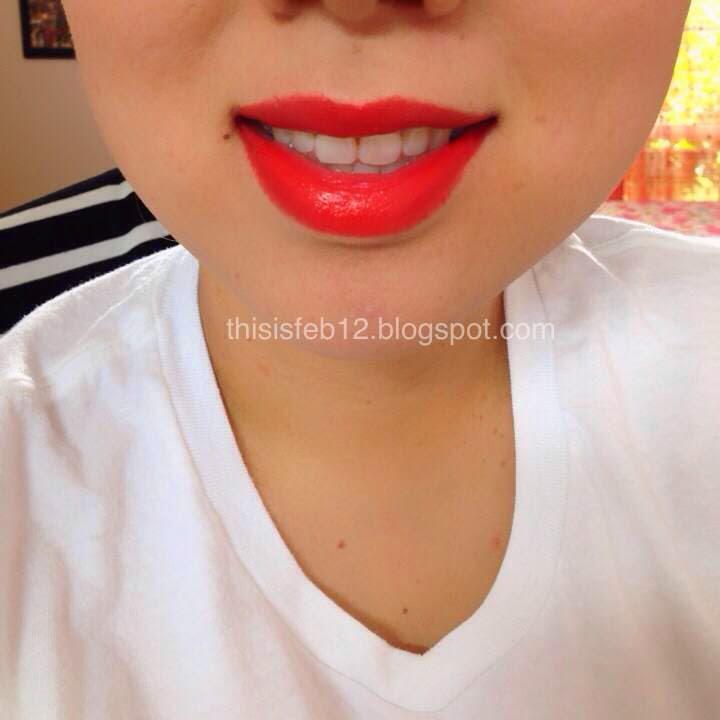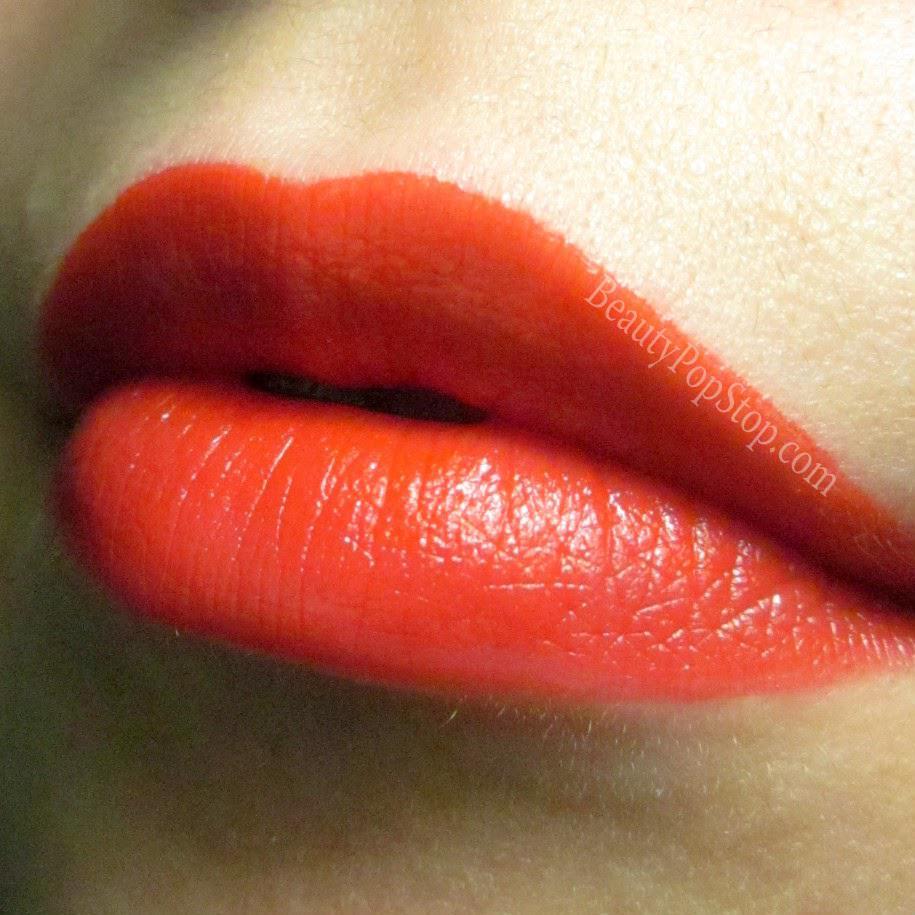The first image is the image on the left, the second image is the image on the right. Examine the images to the left and right. Is the description "One image includes tinted lips, and the other shows a color sample on skin." accurate? Answer yes or no. No. The first image is the image on the left, the second image is the image on the right. Evaluate the accuracy of this statement regarding the images: "There is one lipstick mark across the person's skin on the image on the right.". Is it true? Answer yes or no. No. 